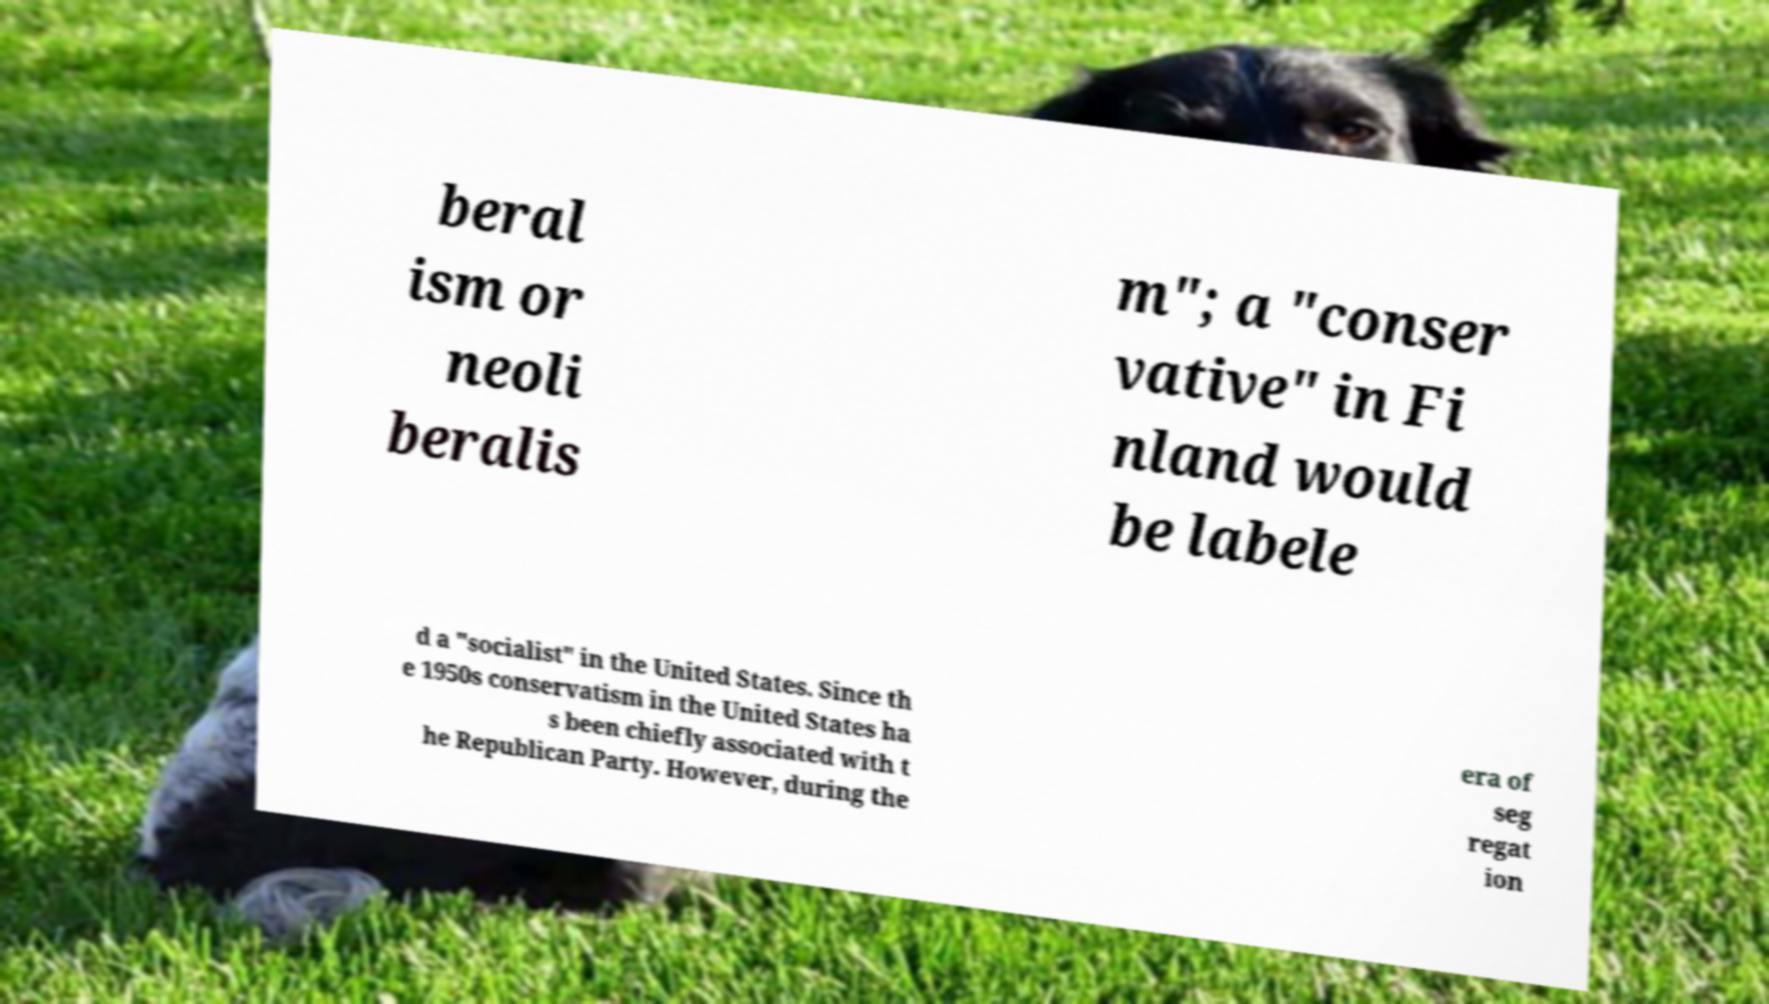Please identify and transcribe the text found in this image. beral ism or neoli beralis m"; a "conser vative" in Fi nland would be labele d a "socialist" in the United States. Since th e 1950s conservatism in the United States ha s been chiefly associated with t he Republican Party. However, during the era of seg regat ion 